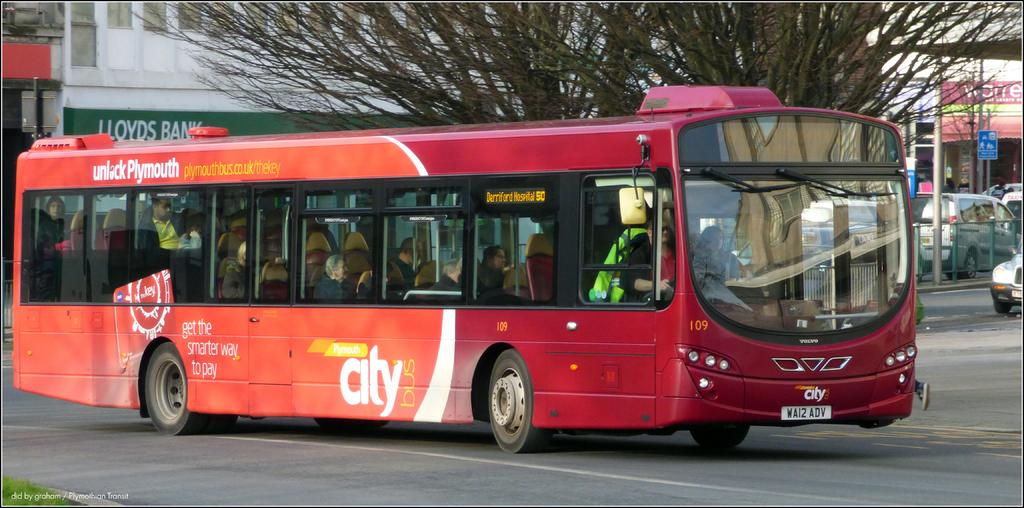<image>
Render a clear and concise summary of the photo. A red bus that says city bus is going down a busy street. 